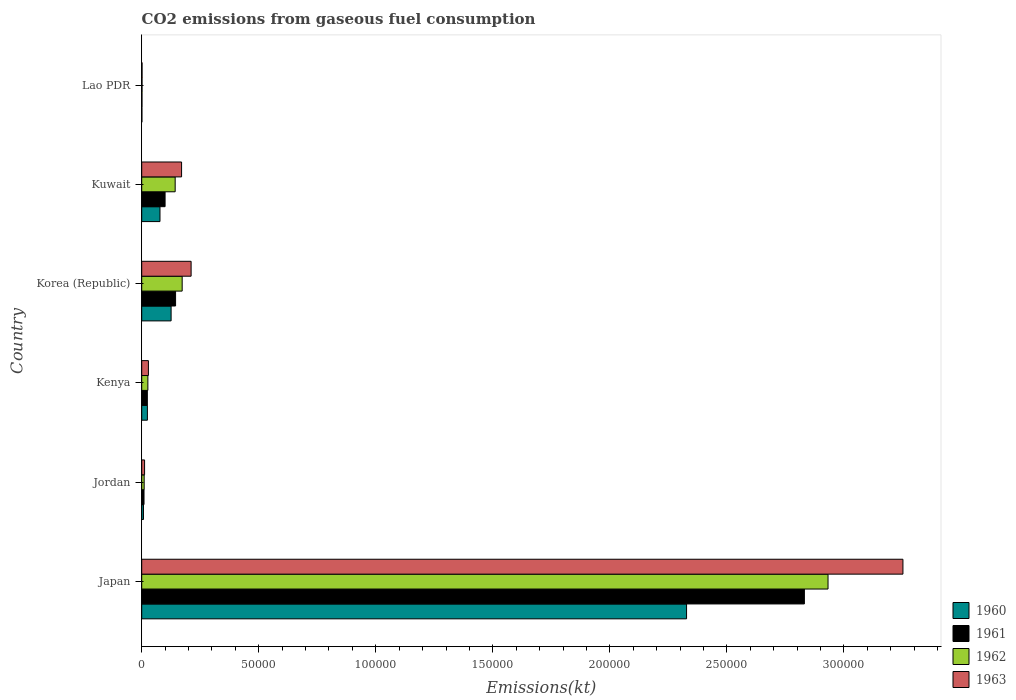What is the label of the 1st group of bars from the top?
Offer a very short reply. Lao PDR. What is the amount of CO2 emitted in 1963 in Jordan?
Your answer should be compact. 1221.11. Across all countries, what is the maximum amount of CO2 emitted in 1961?
Provide a short and direct response. 2.83e+05. Across all countries, what is the minimum amount of CO2 emitted in 1961?
Offer a very short reply. 113.68. In which country was the amount of CO2 emitted in 1963 minimum?
Offer a very short reply. Lao PDR. What is the total amount of CO2 emitted in 1962 in the graph?
Make the answer very short. 3.29e+05. What is the difference between the amount of CO2 emitted in 1960 in Japan and that in Kenya?
Give a very brief answer. 2.30e+05. What is the difference between the amount of CO2 emitted in 1961 in Japan and the amount of CO2 emitted in 1960 in Lao PDR?
Your response must be concise. 2.83e+05. What is the average amount of CO2 emitted in 1960 per country?
Offer a very short reply. 4.27e+04. What is the difference between the amount of CO2 emitted in 1960 and amount of CO2 emitted in 1963 in Japan?
Your answer should be compact. -9.24e+04. What is the ratio of the amount of CO2 emitted in 1961 in Korea (Republic) to that in Lao PDR?
Offer a very short reply. 127.23. Is the difference between the amount of CO2 emitted in 1960 in Kuwait and Lao PDR greater than the difference between the amount of CO2 emitted in 1963 in Kuwait and Lao PDR?
Your response must be concise. No. What is the difference between the highest and the second highest amount of CO2 emitted in 1962?
Keep it short and to the point. 2.76e+05. What is the difference between the highest and the lowest amount of CO2 emitted in 1963?
Make the answer very short. 3.25e+05. What does the 3rd bar from the top in Korea (Republic) represents?
Your response must be concise. 1961. What does the 3rd bar from the bottom in Japan represents?
Provide a short and direct response. 1962. Are all the bars in the graph horizontal?
Your answer should be compact. Yes. Where does the legend appear in the graph?
Offer a terse response. Bottom right. How many legend labels are there?
Make the answer very short. 4. How are the legend labels stacked?
Offer a very short reply. Vertical. What is the title of the graph?
Provide a succinct answer. CO2 emissions from gaseous fuel consumption. What is the label or title of the X-axis?
Your answer should be very brief. Emissions(kt). What is the label or title of the Y-axis?
Keep it short and to the point. Country. What is the Emissions(kt) of 1960 in Japan?
Offer a terse response. 2.33e+05. What is the Emissions(kt) in 1961 in Japan?
Your response must be concise. 2.83e+05. What is the Emissions(kt) of 1962 in Japan?
Your response must be concise. 2.93e+05. What is the Emissions(kt) in 1963 in Japan?
Your answer should be very brief. 3.25e+05. What is the Emissions(kt) of 1960 in Jordan?
Offer a very short reply. 744.4. What is the Emissions(kt) of 1961 in Jordan?
Offer a very short reply. 979.09. What is the Emissions(kt) of 1962 in Jordan?
Your answer should be compact. 1048.76. What is the Emissions(kt) of 1963 in Jordan?
Give a very brief answer. 1221.11. What is the Emissions(kt) of 1960 in Kenya?
Keep it short and to the point. 2427.55. What is the Emissions(kt) of 1961 in Kenya?
Your answer should be very brief. 2401.89. What is the Emissions(kt) in 1962 in Kenya?
Make the answer very short. 2625.57. What is the Emissions(kt) in 1963 in Kenya?
Ensure brevity in your answer.  2856.59. What is the Emissions(kt) in 1960 in Korea (Republic)?
Your response must be concise. 1.26e+04. What is the Emissions(kt) of 1961 in Korea (Republic)?
Your response must be concise. 1.45e+04. What is the Emissions(kt) in 1962 in Korea (Republic)?
Give a very brief answer. 1.73e+04. What is the Emissions(kt) in 1963 in Korea (Republic)?
Your response must be concise. 2.11e+04. What is the Emissions(kt) in 1960 in Kuwait?
Provide a succinct answer. 7803.38. What is the Emissions(kt) of 1961 in Kuwait?
Your answer should be compact. 9981.57. What is the Emissions(kt) in 1962 in Kuwait?
Ensure brevity in your answer.  1.43e+04. What is the Emissions(kt) of 1963 in Kuwait?
Provide a succinct answer. 1.70e+04. What is the Emissions(kt) in 1960 in Lao PDR?
Your response must be concise. 80.67. What is the Emissions(kt) in 1961 in Lao PDR?
Offer a terse response. 113.68. What is the Emissions(kt) of 1962 in Lao PDR?
Your response must be concise. 132.01. What is the Emissions(kt) in 1963 in Lao PDR?
Your answer should be compact. 146.68. Across all countries, what is the maximum Emissions(kt) in 1960?
Keep it short and to the point. 2.33e+05. Across all countries, what is the maximum Emissions(kt) of 1961?
Your response must be concise. 2.83e+05. Across all countries, what is the maximum Emissions(kt) of 1962?
Make the answer very short. 2.93e+05. Across all countries, what is the maximum Emissions(kt) of 1963?
Your response must be concise. 3.25e+05. Across all countries, what is the minimum Emissions(kt) of 1960?
Your answer should be very brief. 80.67. Across all countries, what is the minimum Emissions(kt) of 1961?
Provide a short and direct response. 113.68. Across all countries, what is the minimum Emissions(kt) in 1962?
Offer a very short reply. 132.01. Across all countries, what is the minimum Emissions(kt) of 1963?
Your answer should be compact. 146.68. What is the total Emissions(kt) of 1960 in the graph?
Provide a short and direct response. 2.56e+05. What is the total Emissions(kt) of 1961 in the graph?
Offer a terse response. 3.11e+05. What is the total Emissions(kt) of 1962 in the graph?
Keep it short and to the point. 3.29e+05. What is the total Emissions(kt) in 1963 in the graph?
Ensure brevity in your answer.  3.68e+05. What is the difference between the Emissions(kt) in 1960 in Japan and that in Jordan?
Make the answer very short. 2.32e+05. What is the difference between the Emissions(kt) in 1961 in Japan and that in Jordan?
Provide a succinct answer. 2.82e+05. What is the difference between the Emissions(kt) in 1962 in Japan and that in Jordan?
Your answer should be very brief. 2.92e+05. What is the difference between the Emissions(kt) of 1963 in Japan and that in Jordan?
Offer a very short reply. 3.24e+05. What is the difference between the Emissions(kt) in 1960 in Japan and that in Kenya?
Keep it short and to the point. 2.30e+05. What is the difference between the Emissions(kt) of 1961 in Japan and that in Kenya?
Ensure brevity in your answer.  2.81e+05. What is the difference between the Emissions(kt) of 1962 in Japan and that in Kenya?
Give a very brief answer. 2.91e+05. What is the difference between the Emissions(kt) of 1963 in Japan and that in Kenya?
Provide a short and direct response. 3.22e+05. What is the difference between the Emissions(kt) in 1960 in Japan and that in Korea (Republic)?
Provide a short and direct response. 2.20e+05. What is the difference between the Emissions(kt) of 1961 in Japan and that in Korea (Republic)?
Offer a very short reply. 2.69e+05. What is the difference between the Emissions(kt) of 1962 in Japan and that in Korea (Republic)?
Make the answer very short. 2.76e+05. What is the difference between the Emissions(kt) in 1963 in Japan and that in Korea (Republic)?
Your response must be concise. 3.04e+05. What is the difference between the Emissions(kt) of 1960 in Japan and that in Kuwait?
Ensure brevity in your answer.  2.25e+05. What is the difference between the Emissions(kt) in 1961 in Japan and that in Kuwait?
Provide a succinct answer. 2.73e+05. What is the difference between the Emissions(kt) in 1962 in Japan and that in Kuwait?
Your answer should be compact. 2.79e+05. What is the difference between the Emissions(kt) in 1963 in Japan and that in Kuwait?
Keep it short and to the point. 3.08e+05. What is the difference between the Emissions(kt) in 1960 in Japan and that in Lao PDR?
Your answer should be compact. 2.33e+05. What is the difference between the Emissions(kt) of 1961 in Japan and that in Lao PDR?
Make the answer very short. 2.83e+05. What is the difference between the Emissions(kt) in 1962 in Japan and that in Lao PDR?
Provide a succinct answer. 2.93e+05. What is the difference between the Emissions(kt) in 1963 in Japan and that in Lao PDR?
Offer a very short reply. 3.25e+05. What is the difference between the Emissions(kt) in 1960 in Jordan and that in Kenya?
Offer a terse response. -1683.15. What is the difference between the Emissions(kt) in 1961 in Jordan and that in Kenya?
Your response must be concise. -1422.8. What is the difference between the Emissions(kt) of 1962 in Jordan and that in Kenya?
Provide a succinct answer. -1576.81. What is the difference between the Emissions(kt) of 1963 in Jordan and that in Kenya?
Offer a very short reply. -1635.48. What is the difference between the Emissions(kt) in 1960 in Jordan and that in Korea (Republic)?
Provide a short and direct response. -1.18e+04. What is the difference between the Emissions(kt) in 1961 in Jordan and that in Korea (Republic)?
Give a very brief answer. -1.35e+04. What is the difference between the Emissions(kt) in 1962 in Jordan and that in Korea (Republic)?
Ensure brevity in your answer.  -1.62e+04. What is the difference between the Emissions(kt) of 1963 in Jordan and that in Korea (Republic)?
Give a very brief answer. -1.99e+04. What is the difference between the Emissions(kt) of 1960 in Jordan and that in Kuwait?
Offer a very short reply. -7058.98. What is the difference between the Emissions(kt) of 1961 in Jordan and that in Kuwait?
Your response must be concise. -9002.49. What is the difference between the Emissions(kt) of 1962 in Jordan and that in Kuwait?
Offer a terse response. -1.32e+04. What is the difference between the Emissions(kt) of 1963 in Jordan and that in Kuwait?
Make the answer very short. -1.58e+04. What is the difference between the Emissions(kt) in 1960 in Jordan and that in Lao PDR?
Offer a very short reply. 663.73. What is the difference between the Emissions(kt) of 1961 in Jordan and that in Lao PDR?
Provide a succinct answer. 865.41. What is the difference between the Emissions(kt) in 1962 in Jordan and that in Lao PDR?
Provide a succinct answer. 916.75. What is the difference between the Emissions(kt) of 1963 in Jordan and that in Lao PDR?
Your answer should be compact. 1074.43. What is the difference between the Emissions(kt) of 1960 in Kenya and that in Korea (Republic)?
Make the answer very short. -1.01e+04. What is the difference between the Emissions(kt) of 1961 in Kenya and that in Korea (Republic)?
Offer a terse response. -1.21e+04. What is the difference between the Emissions(kt) of 1962 in Kenya and that in Korea (Republic)?
Your answer should be compact. -1.47e+04. What is the difference between the Emissions(kt) of 1963 in Kenya and that in Korea (Republic)?
Your answer should be very brief. -1.82e+04. What is the difference between the Emissions(kt) of 1960 in Kenya and that in Kuwait?
Your response must be concise. -5375.82. What is the difference between the Emissions(kt) of 1961 in Kenya and that in Kuwait?
Keep it short and to the point. -7579.69. What is the difference between the Emissions(kt) of 1962 in Kenya and that in Kuwait?
Provide a succinct answer. -1.17e+04. What is the difference between the Emissions(kt) in 1963 in Kenya and that in Kuwait?
Offer a very short reply. -1.42e+04. What is the difference between the Emissions(kt) in 1960 in Kenya and that in Lao PDR?
Your answer should be compact. 2346.88. What is the difference between the Emissions(kt) in 1961 in Kenya and that in Lao PDR?
Your response must be concise. 2288.21. What is the difference between the Emissions(kt) of 1962 in Kenya and that in Lao PDR?
Offer a very short reply. 2493.56. What is the difference between the Emissions(kt) in 1963 in Kenya and that in Lao PDR?
Provide a succinct answer. 2709.91. What is the difference between the Emissions(kt) in 1960 in Korea (Republic) and that in Kuwait?
Provide a succinct answer. 4748.77. What is the difference between the Emissions(kt) in 1961 in Korea (Republic) and that in Kuwait?
Your answer should be very brief. 4481.07. What is the difference between the Emissions(kt) in 1962 in Korea (Republic) and that in Kuwait?
Your response must be concise. 2988.61. What is the difference between the Emissions(kt) in 1963 in Korea (Republic) and that in Kuwait?
Give a very brief answer. 4077.7. What is the difference between the Emissions(kt) in 1960 in Korea (Republic) and that in Lao PDR?
Your answer should be very brief. 1.25e+04. What is the difference between the Emissions(kt) in 1961 in Korea (Republic) and that in Lao PDR?
Offer a terse response. 1.43e+04. What is the difference between the Emissions(kt) of 1962 in Korea (Republic) and that in Lao PDR?
Your answer should be compact. 1.71e+04. What is the difference between the Emissions(kt) in 1963 in Korea (Republic) and that in Lao PDR?
Keep it short and to the point. 2.10e+04. What is the difference between the Emissions(kt) in 1960 in Kuwait and that in Lao PDR?
Ensure brevity in your answer.  7722.7. What is the difference between the Emissions(kt) in 1961 in Kuwait and that in Lao PDR?
Your response must be concise. 9867.9. What is the difference between the Emissions(kt) in 1962 in Kuwait and that in Lao PDR?
Your answer should be compact. 1.42e+04. What is the difference between the Emissions(kt) in 1963 in Kuwait and that in Lao PDR?
Your answer should be very brief. 1.69e+04. What is the difference between the Emissions(kt) in 1960 in Japan and the Emissions(kt) in 1961 in Jordan?
Your answer should be very brief. 2.32e+05. What is the difference between the Emissions(kt) in 1960 in Japan and the Emissions(kt) in 1962 in Jordan?
Your answer should be compact. 2.32e+05. What is the difference between the Emissions(kt) in 1960 in Japan and the Emissions(kt) in 1963 in Jordan?
Your response must be concise. 2.32e+05. What is the difference between the Emissions(kt) in 1961 in Japan and the Emissions(kt) in 1962 in Jordan?
Provide a short and direct response. 2.82e+05. What is the difference between the Emissions(kt) of 1961 in Japan and the Emissions(kt) of 1963 in Jordan?
Give a very brief answer. 2.82e+05. What is the difference between the Emissions(kt) in 1962 in Japan and the Emissions(kt) in 1963 in Jordan?
Give a very brief answer. 2.92e+05. What is the difference between the Emissions(kt) of 1960 in Japan and the Emissions(kt) of 1961 in Kenya?
Your answer should be very brief. 2.30e+05. What is the difference between the Emissions(kt) of 1960 in Japan and the Emissions(kt) of 1962 in Kenya?
Keep it short and to the point. 2.30e+05. What is the difference between the Emissions(kt) of 1960 in Japan and the Emissions(kt) of 1963 in Kenya?
Your answer should be compact. 2.30e+05. What is the difference between the Emissions(kt) of 1961 in Japan and the Emissions(kt) of 1962 in Kenya?
Your answer should be compact. 2.80e+05. What is the difference between the Emissions(kt) in 1961 in Japan and the Emissions(kt) in 1963 in Kenya?
Offer a very short reply. 2.80e+05. What is the difference between the Emissions(kt) of 1962 in Japan and the Emissions(kt) of 1963 in Kenya?
Your response must be concise. 2.90e+05. What is the difference between the Emissions(kt) in 1960 in Japan and the Emissions(kt) in 1961 in Korea (Republic)?
Your response must be concise. 2.18e+05. What is the difference between the Emissions(kt) in 1960 in Japan and the Emissions(kt) in 1962 in Korea (Republic)?
Keep it short and to the point. 2.16e+05. What is the difference between the Emissions(kt) of 1960 in Japan and the Emissions(kt) of 1963 in Korea (Republic)?
Provide a short and direct response. 2.12e+05. What is the difference between the Emissions(kt) in 1961 in Japan and the Emissions(kt) in 1962 in Korea (Republic)?
Your answer should be compact. 2.66e+05. What is the difference between the Emissions(kt) in 1961 in Japan and the Emissions(kt) in 1963 in Korea (Republic)?
Your answer should be compact. 2.62e+05. What is the difference between the Emissions(kt) of 1962 in Japan and the Emissions(kt) of 1963 in Korea (Republic)?
Offer a terse response. 2.72e+05. What is the difference between the Emissions(kt) of 1960 in Japan and the Emissions(kt) of 1961 in Kuwait?
Keep it short and to the point. 2.23e+05. What is the difference between the Emissions(kt) in 1960 in Japan and the Emissions(kt) in 1962 in Kuwait?
Offer a very short reply. 2.18e+05. What is the difference between the Emissions(kt) of 1960 in Japan and the Emissions(kt) of 1963 in Kuwait?
Your answer should be very brief. 2.16e+05. What is the difference between the Emissions(kt) of 1961 in Japan and the Emissions(kt) of 1962 in Kuwait?
Offer a very short reply. 2.69e+05. What is the difference between the Emissions(kt) of 1961 in Japan and the Emissions(kt) of 1963 in Kuwait?
Ensure brevity in your answer.  2.66e+05. What is the difference between the Emissions(kt) of 1962 in Japan and the Emissions(kt) of 1963 in Kuwait?
Make the answer very short. 2.76e+05. What is the difference between the Emissions(kt) in 1960 in Japan and the Emissions(kt) in 1961 in Lao PDR?
Keep it short and to the point. 2.33e+05. What is the difference between the Emissions(kt) of 1960 in Japan and the Emissions(kt) of 1962 in Lao PDR?
Give a very brief answer. 2.33e+05. What is the difference between the Emissions(kt) of 1960 in Japan and the Emissions(kt) of 1963 in Lao PDR?
Your answer should be very brief. 2.33e+05. What is the difference between the Emissions(kt) in 1961 in Japan and the Emissions(kt) in 1962 in Lao PDR?
Keep it short and to the point. 2.83e+05. What is the difference between the Emissions(kt) of 1961 in Japan and the Emissions(kt) of 1963 in Lao PDR?
Your answer should be very brief. 2.83e+05. What is the difference between the Emissions(kt) of 1962 in Japan and the Emissions(kt) of 1963 in Lao PDR?
Your answer should be compact. 2.93e+05. What is the difference between the Emissions(kt) of 1960 in Jordan and the Emissions(kt) of 1961 in Kenya?
Your answer should be very brief. -1657.48. What is the difference between the Emissions(kt) of 1960 in Jordan and the Emissions(kt) of 1962 in Kenya?
Offer a very short reply. -1881.17. What is the difference between the Emissions(kt) in 1960 in Jordan and the Emissions(kt) in 1963 in Kenya?
Your answer should be very brief. -2112.19. What is the difference between the Emissions(kt) of 1961 in Jordan and the Emissions(kt) of 1962 in Kenya?
Keep it short and to the point. -1646.48. What is the difference between the Emissions(kt) in 1961 in Jordan and the Emissions(kt) in 1963 in Kenya?
Keep it short and to the point. -1877.5. What is the difference between the Emissions(kt) in 1962 in Jordan and the Emissions(kt) in 1963 in Kenya?
Give a very brief answer. -1807.83. What is the difference between the Emissions(kt) of 1960 in Jordan and the Emissions(kt) of 1961 in Korea (Republic)?
Your answer should be compact. -1.37e+04. What is the difference between the Emissions(kt) in 1960 in Jordan and the Emissions(kt) in 1962 in Korea (Republic)?
Ensure brevity in your answer.  -1.65e+04. What is the difference between the Emissions(kt) in 1960 in Jordan and the Emissions(kt) in 1963 in Korea (Republic)?
Your answer should be compact. -2.04e+04. What is the difference between the Emissions(kt) of 1961 in Jordan and the Emissions(kt) of 1962 in Korea (Republic)?
Make the answer very short. -1.63e+04. What is the difference between the Emissions(kt) of 1961 in Jordan and the Emissions(kt) of 1963 in Korea (Republic)?
Give a very brief answer. -2.01e+04. What is the difference between the Emissions(kt) of 1962 in Jordan and the Emissions(kt) of 1963 in Korea (Republic)?
Keep it short and to the point. -2.01e+04. What is the difference between the Emissions(kt) in 1960 in Jordan and the Emissions(kt) in 1961 in Kuwait?
Your response must be concise. -9237.17. What is the difference between the Emissions(kt) in 1960 in Jordan and the Emissions(kt) in 1962 in Kuwait?
Keep it short and to the point. -1.35e+04. What is the difference between the Emissions(kt) in 1960 in Jordan and the Emissions(kt) in 1963 in Kuwait?
Your answer should be very brief. -1.63e+04. What is the difference between the Emissions(kt) of 1961 in Jordan and the Emissions(kt) of 1962 in Kuwait?
Your answer should be very brief. -1.33e+04. What is the difference between the Emissions(kt) of 1961 in Jordan and the Emissions(kt) of 1963 in Kuwait?
Ensure brevity in your answer.  -1.60e+04. What is the difference between the Emissions(kt) in 1962 in Jordan and the Emissions(kt) in 1963 in Kuwait?
Give a very brief answer. -1.60e+04. What is the difference between the Emissions(kt) in 1960 in Jordan and the Emissions(kt) in 1961 in Lao PDR?
Your answer should be very brief. 630.72. What is the difference between the Emissions(kt) in 1960 in Jordan and the Emissions(kt) in 1962 in Lao PDR?
Offer a very short reply. 612.39. What is the difference between the Emissions(kt) of 1960 in Jordan and the Emissions(kt) of 1963 in Lao PDR?
Offer a very short reply. 597.72. What is the difference between the Emissions(kt) of 1961 in Jordan and the Emissions(kt) of 1962 in Lao PDR?
Give a very brief answer. 847.08. What is the difference between the Emissions(kt) in 1961 in Jordan and the Emissions(kt) in 1963 in Lao PDR?
Ensure brevity in your answer.  832.41. What is the difference between the Emissions(kt) of 1962 in Jordan and the Emissions(kt) of 1963 in Lao PDR?
Offer a very short reply. 902.08. What is the difference between the Emissions(kt) in 1960 in Kenya and the Emissions(kt) in 1961 in Korea (Republic)?
Offer a terse response. -1.20e+04. What is the difference between the Emissions(kt) in 1960 in Kenya and the Emissions(kt) in 1962 in Korea (Republic)?
Keep it short and to the point. -1.49e+04. What is the difference between the Emissions(kt) of 1960 in Kenya and the Emissions(kt) of 1963 in Korea (Republic)?
Your response must be concise. -1.87e+04. What is the difference between the Emissions(kt) in 1961 in Kenya and the Emissions(kt) in 1962 in Korea (Republic)?
Give a very brief answer. -1.49e+04. What is the difference between the Emissions(kt) in 1961 in Kenya and the Emissions(kt) in 1963 in Korea (Republic)?
Give a very brief answer. -1.87e+04. What is the difference between the Emissions(kt) in 1962 in Kenya and the Emissions(kt) in 1963 in Korea (Republic)?
Your answer should be very brief. -1.85e+04. What is the difference between the Emissions(kt) of 1960 in Kenya and the Emissions(kt) of 1961 in Kuwait?
Offer a terse response. -7554.02. What is the difference between the Emissions(kt) in 1960 in Kenya and the Emissions(kt) in 1962 in Kuwait?
Provide a short and direct response. -1.19e+04. What is the difference between the Emissions(kt) of 1960 in Kenya and the Emissions(kt) of 1963 in Kuwait?
Provide a short and direct response. -1.46e+04. What is the difference between the Emissions(kt) in 1961 in Kenya and the Emissions(kt) in 1962 in Kuwait?
Keep it short and to the point. -1.19e+04. What is the difference between the Emissions(kt) in 1961 in Kenya and the Emissions(kt) in 1963 in Kuwait?
Offer a terse response. -1.46e+04. What is the difference between the Emissions(kt) of 1962 in Kenya and the Emissions(kt) of 1963 in Kuwait?
Provide a succinct answer. -1.44e+04. What is the difference between the Emissions(kt) of 1960 in Kenya and the Emissions(kt) of 1961 in Lao PDR?
Your answer should be compact. 2313.88. What is the difference between the Emissions(kt) in 1960 in Kenya and the Emissions(kt) in 1962 in Lao PDR?
Your response must be concise. 2295.54. What is the difference between the Emissions(kt) of 1960 in Kenya and the Emissions(kt) of 1963 in Lao PDR?
Provide a short and direct response. 2280.87. What is the difference between the Emissions(kt) in 1961 in Kenya and the Emissions(kt) in 1962 in Lao PDR?
Offer a very short reply. 2269.87. What is the difference between the Emissions(kt) in 1961 in Kenya and the Emissions(kt) in 1963 in Lao PDR?
Ensure brevity in your answer.  2255.2. What is the difference between the Emissions(kt) in 1962 in Kenya and the Emissions(kt) in 1963 in Lao PDR?
Offer a very short reply. 2478.89. What is the difference between the Emissions(kt) of 1960 in Korea (Republic) and the Emissions(kt) of 1961 in Kuwait?
Ensure brevity in your answer.  2570.57. What is the difference between the Emissions(kt) in 1960 in Korea (Republic) and the Emissions(kt) in 1962 in Kuwait?
Keep it short and to the point. -1738.16. What is the difference between the Emissions(kt) in 1960 in Korea (Republic) and the Emissions(kt) in 1963 in Kuwait?
Make the answer very short. -4473.74. What is the difference between the Emissions(kt) of 1961 in Korea (Republic) and the Emissions(kt) of 1962 in Kuwait?
Offer a very short reply. 172.35. What is the difference between the Emissions(kt) of 1961 in Korea (Republic) and the Emissions(kt) of 1963 in Kuwait?
Your response must be concise. -2563.23. What is the difference between the Emissions(kt) of 1962 in Korea (Republic) and the Emissions(kt) of 1963 in Kuwait?
Offer a very short reply. 253.02. What is the difference between the Emissions(kt) of 1960 in Korea (Republic) and the Emissions(kt) of 1961 in Lao PDR?
Offer a terse response. 1.24e+04. What is the difference between the Emissions(kt) in 1960 in Korea (Republic) and the Emissions(kt) in 1962 in Lao PDR?
Provide a short and direct response. 1.24e+04. What is the difference between the Emissions(kt) in 1960 in Korea (Republic) and the Emissions(kt) in 1963 in Lao PDR?
Your answer should be compact. 1.24e+04. What is the difference between the Emissions(kt) of 1961 in Korea (Republic) and the Emissions(kt) of 1962 in Lao PDR?
Give a very brief answer. 1.43e+04. What is the difference between the Emissions(kt) of 1961 in Korea (Republic) and the Emissions(kt) of 1963 in Lao PDR?
Offer a very short reply. 1.43e+04. What is the difference between the Emissions(kt) of 1962 in Korea (Republic) and the Emissions(kt) of 1963 in Lao PDR?
Provide a succinct answer. 1.71e+04. What is the difference between the Emissions(kt) of 1960 in Kuwait and the Emissions(kt) of 1961 in Lao PDR?
Your response must be concise. 7689.7. What is the difference between the Emissions(kt) of 1960 in Kuwait and the Emissions(kt) of 1962 in Lao PDR?
Provide a succinct answer. 7671.36. What is the difference between the Emissions(kt) in 1960 in Kuwait and the Emissions(kt) in 1963 in Lao PDR?
Your answer should be very brief. 7656.7. What is the difference between the Emissions(kt) in 1961 in Kuwait and the Emissions(kt) in 1962 in Lao PDR?
Your response must be concise. 9849.56. What is the difference between the Emissions(kt) of 1961 in Kuwait and the Emissions(kt) of 1963 in Lao PDR?
Offer a very short reply. 9834.89. What is the difference between the Emissions(kt) in 1962 in Kuwait and the Emissions(kt) in 1963 in Lao PDR?
Provide a short and direct response. 1.41e+04. What is the average Emissions(kt) in 1960 per country?
Your answer should be compact. 4.27e+04. What is the average Emissions(kt) of 1961 per country?
Provide a short and direct response. 5.18e+04. What is the average Emissions(kt) of 1962 per country?
Make the answer very short. 5.48e+04. What is the average Emissions(kt) of 1963 per country?
Your answer should be compact. 6.13e+04. What is the difference between the Emissions(kt) in 1960 and Emissions(kt) in 1961 in Japan?
Keep it short and to the point. -5.03e+04. What is the difference between the Emissions(kt) in 1960 and Emissions(kt) in 1962 in Japan?
Make the answer very short. -6.04e+04. What is the difference between the Emissions(kt) in 1960 and Emissions(kt) in 1963 in Japan?
Make the answer very short. -9.24e+04. What is the difference between the Emissions(kt) of 1961 and Emissions(kt) of 1962 in Japan?
Provide a short and direct response. -1.01e+04. What is the difference between the Emissions(kt) of 1961 and Emissions(kt) of 1963 in Japan?
Your answer should be very brief. -4.21e+04. What is the difference between the Emissions(kt) in 1962 and Emissions(kt) in 1963 in Japan?
Keep it short and to the point. -3.20e+04. What is the difference between the Emissions(kt) in 1960 and Emissions(kt) in 1961 in Jordan?
Your answer should be very brief. -234.69. What is the difference between the Emissions(kt) of 1960 and Emissions(kt) of 1962 in Jordan?
Your response must be concise. -304.36. What is the difference between the Emissions(kt) in 1960 and Emissions(kt) in 1963 in Jordan?
Ensure brevity in your answer.  -476.71. What is the difference between the Emissions(kt) of 1961 and Emissions(kt) of 1962 in Jordan?
Your answer should be very brief. -69.67. What is the difference between the Emissions(kt) in 1961 and Emissions(kt) in 1963 in Jordan?
Ensure brevity in your answer.  -242.02. What is the difference between the Emissions(kt) of 1962 and Emissions(kt) of 1963 in Jordan?
Make the answer very short. -172.35. What is the difference between the Emissions(kt) of 1960 and Emissions(kt) of 1961 in Kenya?
Make the answer very short. 25.67. What is the difference between the Emissions(kt) of 1960 and Emissions(kt) of 1962 in Kenya?
Provide a succinct answer. -198.02. What is the difference between the Emissions(kt) of 1960 and Emissions(kt) of 1963 in Kenya?
Provide a short and direct response. -429.04. What is the difference between the Emissions(kt) of 1961 and Emissions(kt) of 1962 in Kenya?
Your response must be concise. -223.69. What is the difference between the Emissions(kt) in 1961 and Emissions(kt) in 1963 in Kenya?
Provide a short and direct response. -454.71. What is the difference between the Emissions(kt) in 1962 and Emissions(kt) in 1963 in Kenya?
Provide a short and direct response. -231.02. What is the difference between the Emissions(kt) of 1960 and Emissions(kt) of 1961 in Korea (Republic)?
Offer a terse response. -1910.51. What is the difference between the Emissions(kt) in 1960 and Emissions(kt) in 1962 in Korea (Republic)?
Your answer should be very brief. -4726.76. What is the difference between the Emissions(kt) of 1960 and Emissions(kt) of 1963 in Korea (Republic)?
Your answer should be compact. -8551.44. What is the difference between the Emissions(kt) of 1961 and Emissions(kt) of 1962 in Korea (Republic)?
Provide a short and direct response. -2816.26. What is the difference between the Emissions(kt) in 1961 and Emissions(kt) in 1963 in Korea (Republic)?
Your answer should be very brief. -6640.94. What is the difference between the Emissions(kt) in 1962 and Emissions(kt) in 1963 in Korea (Republic)?
Keep it short and to the point. -3824.68. What is the difference between the Emissions(kt) in 1960 and Emissions(kt) in 1961 in Kuwait?
Your response must be concise. -2178.2. What is the difference between the Emissions(kt) of 1960 and Emissions(kt) of 1962 in Kuwait?
Make the answer very short. -6486.92. What is the difference between the Emissions(kt) in 1960 and Emissions(kt) in 1963 in Kuwait?
Provide a short and direct response. -9222.5. What is the difference between the Emissions(kt) of 1961 and Emissions(kt) of 1962 in Kuwait?
Offer a terse response. -4308.73. What is the difference between the Emissions(kt) of 1961 and Emissions(kt) of 1963 in Kuwait?
Ensure brevity in your answer.  -7044.31. What is the difference between the Emissions(kt) in 1962 and Emissions(kt) in 1963 in Kuwait?
Your answer should be compact. -2735.58. What is the difference between the Emissions(kt) in 1960 and Emissions(kt) in 1961 in Lao PDR?
Your answer should be compact. -33. What is the difference between the Emissions(kt) of 1960 and Emissions(kt) of 1962 in Lao PDR?
Give a very brief answer. -51.34. What is the difference between the Emissions(kt) in 1960 and Emissions(kt) in 1963 in Lao PDR?
Offer a terse response. -66.01. What is the difference between the Emissions(kt) of 1961 and Emissions(kt) of 1962 in Lao PDR?
Make the answer very short. -18.34. What is the difference between the Emissions(kt) in 1961 and Emissions(kt) in 1963 in Lao PDR?
Offer a terse response. -33. What is the difference between the Emissions(kt) in 1962 and Emissions(kt) in 1963 in Lao PDR?
Your answer should be very brief. -14.67. What is the ratio of the Emissions(kt) of 1960 in Japan to that in Jordan?
Offer a very short reply. 312.71. What is the ratio of the Emissions(kt) in 1961 in Japan to that in Jordan?
Offer a very short reply. 289.16. What is the ratio of the Emissions(kt) of 1962 in Japan to that in Jordan?
Offer a terse response. 279.59. What is the ratio of the Emissions(kt) in 1963 in Japan to that in Jordan?
Your answer should be compact. 266.33. What is the ratio of the Emissions(kt) in 1960 in Japan to that in Kenya?
Your answer should be compact. 95.89. What is the ratio of the Emissions(kt) in 1961 in Japan to that in Kenya?
Provide a succinct answer. 117.87. What is the ratio of the Emissions(kt) in 1962 in Japan to that in Kenya?
Offer a very short reply. 111.68. What is the ratio of the Emissions(kt) in 1963 in Japan to that in Kenya?
Provide a succinct answer. 113.85. What is the ratio of the Emissions(kt) in 1960 in Japan to that in Korea (Republic)?
Ensure brevity in your answer.  18.55. What is the ratio of the Emissions(kt) in 1961 in Japan to that in Korea (Republic)?
Keep it short and to the point. 19.58. What is the ratio of the Emissions(kt) of 1962 in Japan to that in Korea (Republic)?
Your response must be concise. 16.97. What is the ratio of the Emissions(kt) in 1963 in Japan to that in Korea (Republic)?
Offer a very short reply. 15.41. What is the ratio of the Emissions(kt) of 1960 in Japan to that in Kuwait?
Your answer should be compact. 29.83. What is the ratio of the Emissions(kt) in 1961 in Japan to that in Kuwait?
Your response must be concise. 28.36. What is the ratio of the Emissions(kt) of 1962 in Japan to that in Kuwait?
Give a very brief answer. 20.52. What is the ratio of the Emissions(kt) in 1963 in Japan to that in Kuwait?
Your answer should be compact. 19.1. What is the ratio of the Emissions(kt) of 1960 in Japan to that in Lao PDR?
Offer a terse response. 2885.45. What is the ratio of the Emissions(kt) of 1961 in Japan to that in Lao PDR?
Provide a short and direct response. 2490.55. What is the ratio of the Emissions(kt) of 1962 in Japan to that in Lao PDR?
Keep it short and to the point. 2221.17. What is the ratio of the Emissions(kt) of 1963 in Japan to that in Lao PDR?
Provide a short and direct response. 2217.22. What is the ratio of the Emissions(kt) of 1960 in Jordan to that in Kenya?
Provide a succinct answer. 0.31. What is the ratio of the Emissions(kt) of 1961 in Jordan to that in Kenya?
Your answer should be very brief. 0.41. What is the ratio of the Emissions(kt) of 1962 in Jordan to that in Kenya?
Offer a terse response. 0.4. What is the ratio of the Emissions(kt) in 1963 in Jordan to that in Kenya?
Make the answer very short. 0.43. What is the ratio of the Emissions(kt) of 1960 in Jordan to that in Korea (Republic)?
Offer a very short reply. 0.06. What is the ratio of the Emissions(kt) in 1961 in Jordan to that in Korea (Republic)?
Provide a succinct answer. 0.07. What is the ratio of the Emissions(kt) of 1962 in Jordan to that in Korea (Republic)?
Offer a terse response. 0.06. What is the ratio of the Emissions(kt) in 1963 in Jordan to that in Korea (Republic)?
Provide a short and direct response. 0.06. What is the ratio of the Emissions(kt) in 1960 in Jordan to that in Kuwait?
Provide a succinct answer. 0.1. What is the ratio of the Emissions(kt) in 1961 in Jordan to that in Kuwait?
Keep it short and to the point. 0.1. What is the ratio of the Emissions(kt) of 1962 in Jordan to that in Kuwait?
Offer a terse response. 0.07. What is the ratio of the Emissions(kt) in 1963 in Jordan to that in Kuwait?
Your answer should be compact. 0.07. What is the ratio of the Emissions(kt) in 1960 in Jordan to that in Lao PDR?
Your answer should be very brief. 9.23. What is the ratio of the Emissions(kt) in 1961 in Jordan to that in Lao PDR?
Offer a very short reply. 8.61. What is the ratio of the Emissions(kt) in 1962 in Jordan to that in Lao PDR?
Provide a short and direct response. 7.94. What is the ratio of the Emissions(kt) in 1963 in Jordan to that in Lao PDR?
Your answer should be compact. 8.32. What is the ratio of the Emissions(kt) in 1960 in Kenya to that in Korea (Republic)?
Your answer should be very brief. 0.19. What is the ratio of the Emissions(kt) of 1961 in Kenya to that in Korea (Republic)?
Ensure brevity in your answer.  0.17. What is the ratio of the Emissions(kt) in 1962 in Kenya to that in Korea (Republic)?
Ensure brevity in your answer.  0.15. What is the ratio of the Emissions(kt) in 1963 in Kenya to that in Korea (Republic)?
Provide a short and direct response. 0.14. What is the ratio of the Emissions(kt) of 1960 in Kenya to that in Kuwait?
Give a very brief answer. 0.31. What is the ratio of the Emissions(kt) in 1961 in Kenya to that in Kuwait?
Ensure brevity in your answer.  0.24. What is the ratio of the Emissions(kt) of 1962 in Kenya to that in Kuwait?
Give a very brief answer. 0.18. What is the ratio of the Emissions(kt) of 1963 in Kenya to that in Kuwait?
Provide a short and direct response. 0.17. What is the ratio of the Emissions(kt) of 1960 in Kenya to that in Lao PDR?
Your answer should be compact. 30.09. What is the ratio of the Emissions(kt) in 1961 in Kenya to that in Lao PDR?
Offer a terse response. 21.13. What is the ratio of the Emissions(kt) in 1962 in Kenya to that in Lao PDR?
Provide a succinct answer. 19.89. What is the ratio of the Emissions(kt) in 1963 in Kenya to that in Lao PDR?
Keep it short and to the point. 19.48. What is the ratio of the Emissions(kt) in 1960 in Korea (Republic) to that in Kuwait?
Give a very brief answer. 1.61. What is the ratio of the Emissions(kt) of 1961 in Korea (Republic) to that in Kuwait?
Your answer should be compact. 1.45. What is the ratio of the Emissions(kt) of 1962 in Korea (Republic) to that in Kuwait?
Provide a succinct answer. 1.21. What is the ratio of the Emissions(kt) in 1963 in Korea (Republic) to that in Kuwait?
Offer a terse response. 1.24. What is the ratio of the Emissions(kt) of 1960 in Korea (Republic) to that in Lao PDR?
Your answer should be compact. 155.59. What is the ratio of the Emissions(kt) of 1961 in Korea (Republic) to that in Lao PDR?
Provide a short and direct response. 127.23. What is the ratio of the Emissions(kt) of 1962 in Korea (Republic) to that in Lao PDR?
Your response must be concise. 130.89. What is the ratio of the Emissions(kt) in 1963 in Korea (Republic) to that in Lao PDR?
Your response must be concise. 143.88. What is the ratio of the Emissions(kt) in 1960 in Kuwait to that in Lao PDR?
Offer a terse response. 96.73. What is the ratio of the Emissions(kt) in 1961 in Kuwait to that in Lao PDR?
Offer a very short reply. 87.81. What is the ratio of the Emissions(kt) in 1962 in Kuwait to that in Lao PDR?
Ensure brevity in your answer.  108.25. What is the ratio of the Emissions(kt) of 1963 in Kuwait to that in Lao PDR?
Keep it short and to the point. 116.08. What is the difference between the highest and the second highest Emissions(kt) of 1960?
Your answer should be very brief. 2.20e+05. What is the difference between the highest and the second highest Emissions(kt) of 1961?
Your answer should be very brief. 2.69e+05. What is the difference between the highest and the second highest Emissions(kt) in 1962?
Provide a short and direct response. 2.76e+05. What is the difference between the highest and the second highest Emissions(kt) in 1963?
Give a very brief answer. 3.04e+05. What is the difference between the highest and the lowest Emissions(kt) of 1960?
Provide a succinct answer. 2.33e+05. What is the difference between the highest and the lowest Emissions(kt) of 1961?
Give a very brief answer. 2.83e+05. What is the difference between the highest and the lowest Emissions(kt) of 1962?
Ensure brevity in your answer.  2.93e+05. What is the difference between the highest and the lowest Emissions(kt) of 1963?
Make the answer very short. 3.25e+05. 